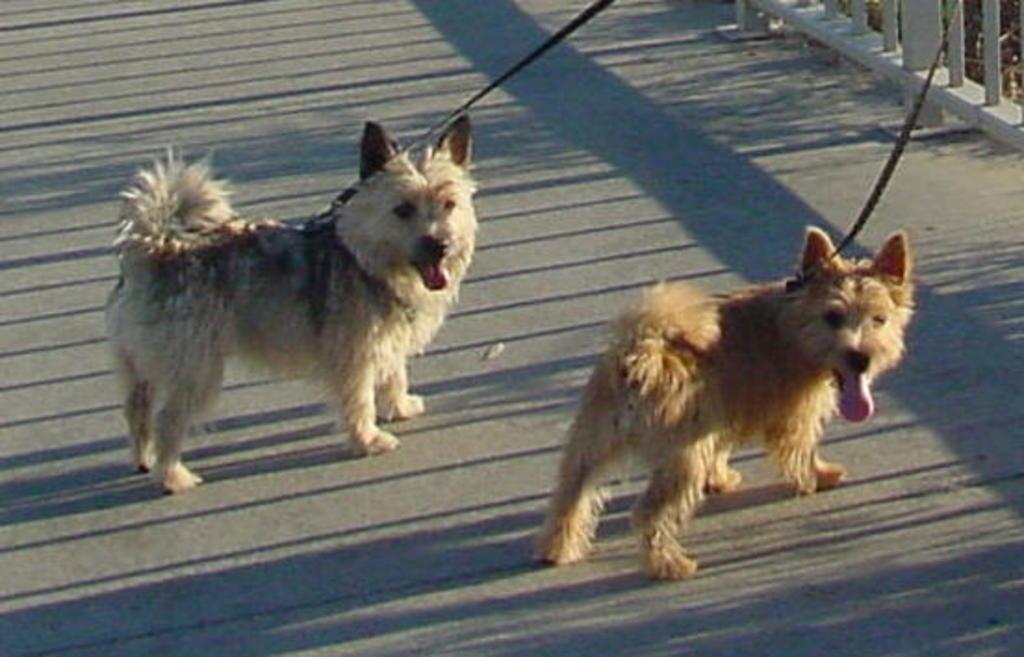Describe this image in one or two sentences. In the image in the center, we can see two dogs, which are in white and brown color. And we can see belts around dog's neck. In the background there is a fence. 